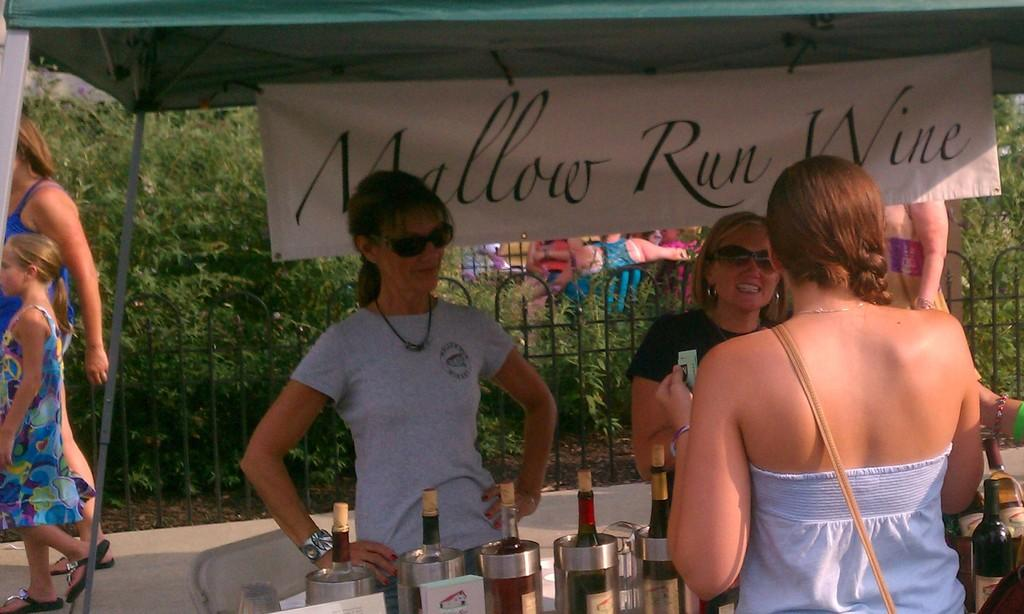What is the main object in the image? There is a table in the image. What can be seen on the table? Wine bottles are present on the table. What are the people doing with the wine bottles? There are people exchanging the wine bottles. What is visible in the background of the image? There is a poster in the background of the image. What is the name of the poster? The poster is named "MALLOW RED WINE". What type of fear can be seen on the faces of the people in the image? There is no indication of fear on the faces of the people in the image; they are exchanging wine bottles. How many toads are present on the table in the image? There are no toads present on the table in the image; only wine bottles are visible. 